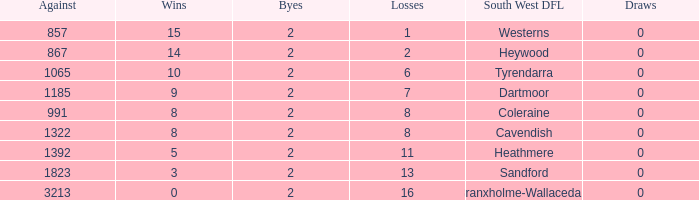Which draws have an average of 14 wins? 0.0. 